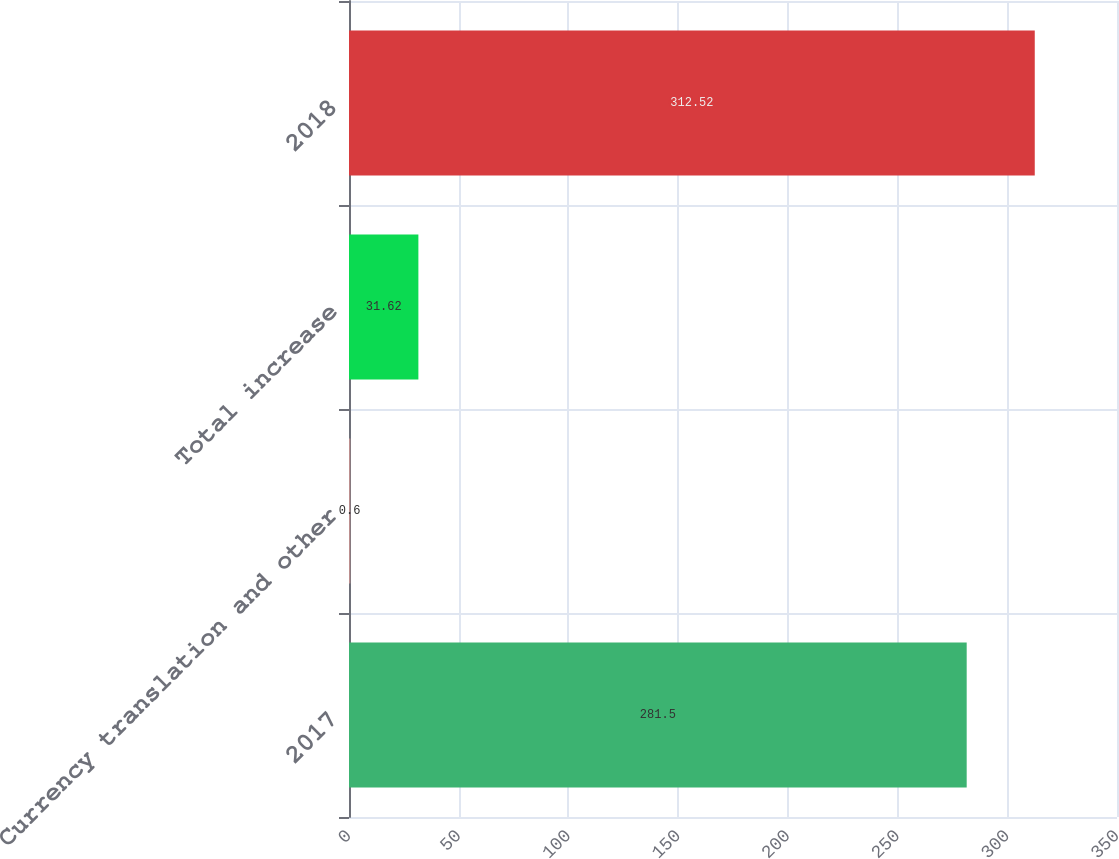<chart> <loc_0><loc_0><loc_500><loc_500><bar_chart><fcel>2017<fcel>Currency translation and other<fcel>Total increase<fcel>2018<nl><fcel>281.5<fcel>0.6<fcel>31.62<fcel>312.52<nl></chart> 